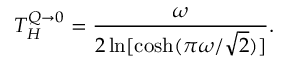Convert formula to latex. <formula><loc_0><loc_0><loc_500><loc_500>T _ { H } ^ { Q \to 0 } = { \frac { \omega } { 2 \ln [ \cosh ( \pi \omega / \sqrt { 2 } ) ] } } .</formula> 